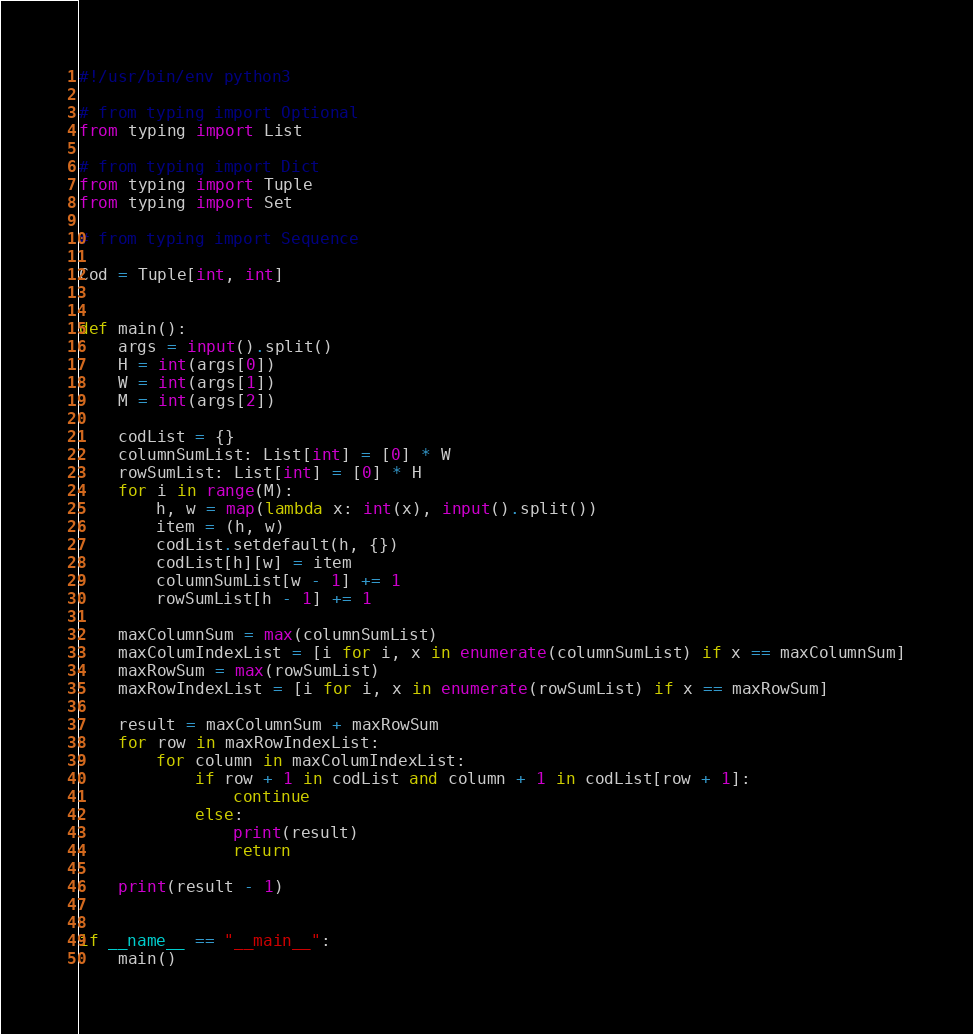<code> <loc_0><loc_0><loc_500><loc_500><_Python_>#!/usr/bin/env python3

# from typing import Optional
from typing import List

# from typing import Dict
from typing import Tuple
from typing import Set

# from typing import Sequence

Cod = Tuple[int, int]


def main():
    args = input().split()
    H = int(args[0])
    W = int(args[1])
    M = int(args[2])

    codList = {}
    columnSumList: List[int] = [0] * W
    rowSumList: List[int] = [0] * H
    for i in range(M):
        h, w = map(lambda x: int(x), input().split())
        item = (h, w)
        codList.setdefault(h, {})
        codList[h][w] = item
        columnSumList[w - 1] += 1
        rowSumList[h - 1] += 1

    maxColumnSum = max(columnSumList)
    maxColumIndexList = [i for i, x in enumerate(columnSumList) if x == maxColumnSum]
    maxRowSum = max(rowSumList)
    maxRowIndexList = [i for i, x in enumerate(rowSumList) if x == maxRowSum]

    result = maxColumnSum + maxRowSum
    for row in maxRowIndexList:
        for column in maxColumIndexList:
            if row + 1 in codList and column + 1 in codList[row + 1]:
                continue
            else:
                print(result)
                return

    print(result - 1)


if __name__ == "__main__":
    main()
</code> 